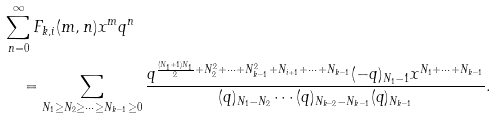Convert formula to latex. <formula><loc_0><loc_0><loc_500><loc_500>& \sum _ { n = 0 } ^ { \infty } F _ { k , i } ( m , n ) x ^ { m } q ^ { n } \\ & \quad = \sum _ { N _ { 1 } \geq N _ { 2 } \geq \cdots \geq N _ { k - 1 } \geq 0 } \frac { q ^ { \frac { ( N _ { 1 } + 1 ) N _ { 1 } } { 2 } + N _ { 2 } ^ { 2 } + \cdots + N _ { k - 1 } ^ { 2 } + N _ { i + 1 } + \cdots + N _ { k - 1 } } ( - q ) _ { N _ { 1 } - 1 } x ^ { N _ { 1 } + \cdots + N _ { k - 1 } } } { ( q ) _ { N _ { 1 } - N _ { 2 } } \cdots ( q ) _ { N _ { k - 2 } - N _ { k - 1 } } ( q ) _ { N _ { k - 1 } } } .</formula> 